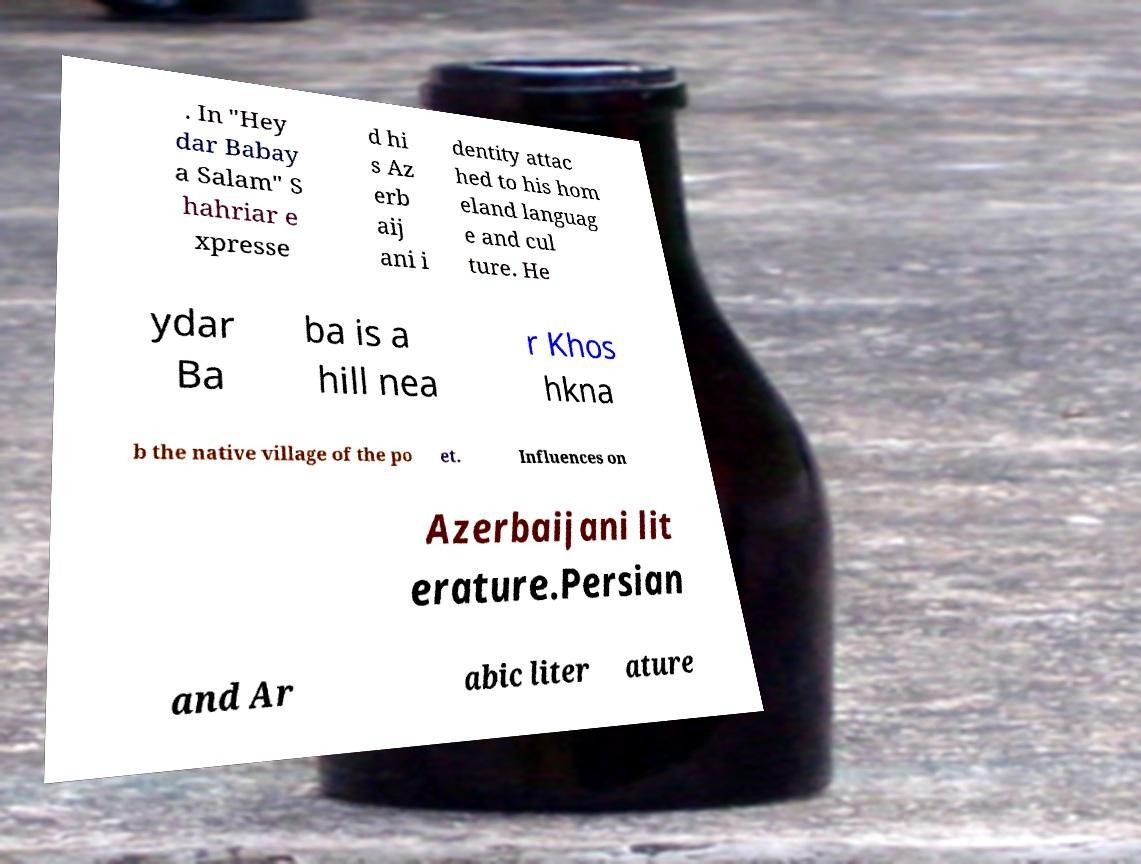For documentation purposes, I need the text within this image transcribed. Could you provide that? . In "Hey dar Babay a Salam" S hahriar e xpresse d hi s Az erb aij ani i dentity attac hed to his hom eland languag e and cul ture. He ydar Ba ba is a hill nea r Khos hkna b the native village of the po et. Influences on Azerbaijani lit erature.Persian and Ar abic liter ature 